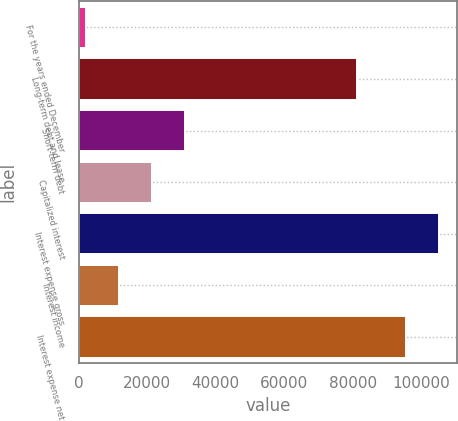Convert chart to OTSL. <chart><loc_0><loc_0><loc_500><loc_500><bar_chart><fcel>For the years ended December<fcel>Long-term debt and lease<fcel>Short-term debt<fcel>Capitalized interest<fcel>Interest expense gross<fcel>Interest income<fcel>Interest expense net<nl><fcel>2012<fcel>81203<fcel>30961.1<fcel>21311.4<fcel>105219<fcel>11661.7<fcel>95569<nl></chart> 